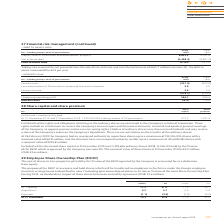According to Intu Properties's financial document, What were the dividends in respect of these shares have been waived by agreement in 2018? According to the financial document, £1.6 million. The relevant text states: "these shares have been waived by agreement (2018: £1.6 million)...." Also, What is the purpose of the ESOP? to acquire and hold shares which will be transferred to employees in the future under the Group’s employee incentive arrangements. The document states: "The purpose of the ESOP is to acquire and hold shares which will be transferred to employees in the future under the Group’s employee incentive arrang..." Also, How are the cost of shares in intu properties plc held by the Trustee of the ESOP operated by the Company accounted for? accounted for as a deduction from equity. The document states: "he Trustee of the ESOP operated by the Company is accounted for as a deduction from equity...." Also, can you calculate: What is the percentage change in the acquisitions value from 2018 to 2019? To answer this question, I need to perform calculations using the financial data. The calculation is: (0.1-0.9)/0.9, which equals -88.89 (percentage). This is based on the information: "Acquisitions 0.2 0.1 0.6 0.9 Acquisitions 0.2 0.1 0.6 0.9..." The key data points involved are: 0.1, 0.9. Also, can you calculate: What is the percentage change in the disposals value from 2018 to 2019? To answer this question, I need to perform calculations using the financial data. The calculation is: (3.5-3.0)/3.0, which equals 16.67 (percentage). This is based on the information: "Disposals (1.1) (3.5) (1.0) (3.0) Disposals (1.1) (3.5) (1.0) (3.0)..." The key data points involved are: 3.0, 3.5. Also, can you calculate: What is the percentage change in the shares from 31 December 2018 to 31 December 2019? To answer this question, I need to perform calculations using the financial data. The calculation is: (10.3-11.2)/11.2, which equals -8.04 (percentage). This is based on the information: "At 31 December 10.3 33.6 11.2 37.0 At 31 December 10.3 33.6 11.2 37.0..." The key data points involved are: 10.3, 11.2. 